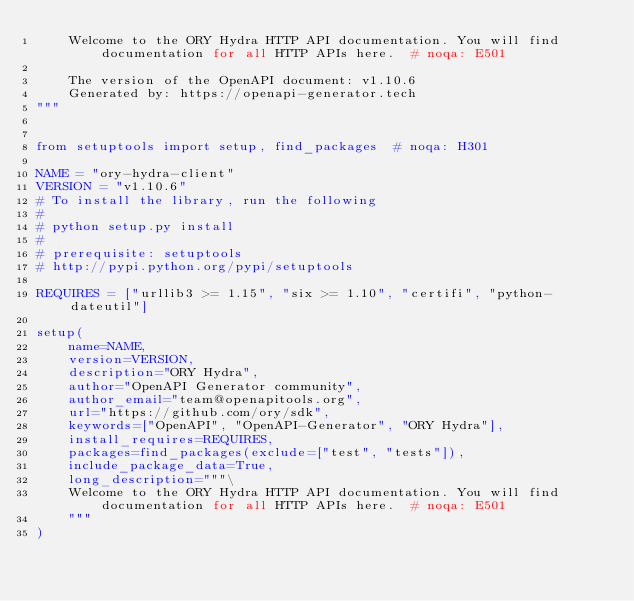<code> <loc_0><loc_0><loc_500><loc_500><_Python_>    Welcome to the ORY Hydra HTTP API documentation. You will find documentation for all HTTP APIs here.  # noqa: E501

    The version of the OpenAPI document: v1.10.6
    Generated by: https://openapi-generator.tech
"""


from setuptools import setup, find_packages  # noqa: H301

NAME = "ory-hydra-client"
VERSION = "v1.10.6"
# To install the library, run the following
#
# python setup.py install
#
# prerequisite: setuptools
# http://pypi.python.org/pypi/setuptools

REQUIRES = ["urllib3 >= 1.15", "six >= 1.10", "certifi", "python-dateutil"]

setup(
    name=NAME,
    version=VERSION,
    description="ORY Hydra",
    author="OpenAPI Generator community",
    author_email="team@openapitools.org",
    url="https://github.com/ory/sdk",
    keywords=["OpenAPI", "OpenAPI-Generator", "ORY Hydra"],
    install_requires=REQUIRES,
    packages=find_packages(exclude=["test", "tests"]),
    include_package_data=True,
    long_description="""\
    Welcome to the ORY Hydra HTTP API documentation. You will find documentation for all HTTP APIs here.  # noqa: E501
    """
)
</code> 